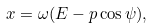<formula> <loc_0><loc_0><loc_500><loc_500>x = \omega ( E - p \cos \psi ) ,</formula> 